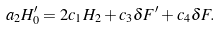Convert formula to latex. <formula><loc_0><loc_0><loc_500><loc_500>a _ { 2 } H _ { 0 } ^ { \prime } = 2 c _ { 1 } H _ { 2 } + c _ { 3 } \delta F ^ { \prime } + c _ { 4 } \delta F .</formula> 